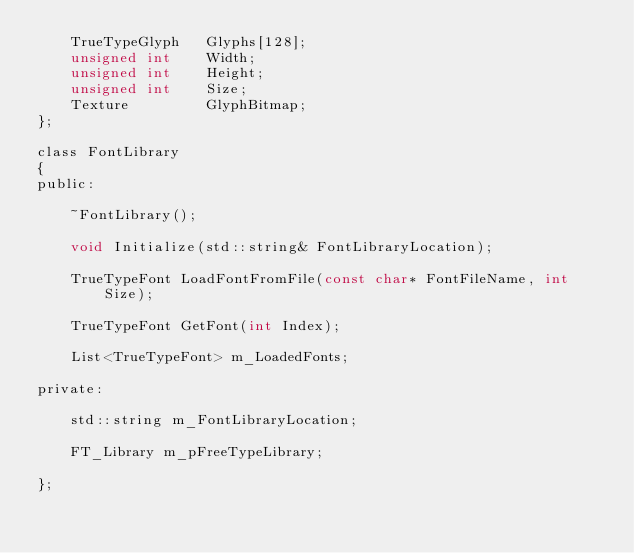Convert code to text. <code><loc_0><loc_0><loc_500><loc_500><_C_>	TrueTypeGlyph	Glyphs[128];
	unsigned int	Width;
	unsigned int	Height;
	unsigned int	Size;
	Texture			GlyphBitmap;
};

class FontLibrary
{
public:
    
    ~FontLibrary();

	void Initialize(std::string& FontLibraryLocation);

	TrueTypeFont LoadFontFromFile(const char* FontFileName, int Size);

	TrueTypeFont GetFont(int Index);
	
	List<TrueTypeFont> m_LoadedFonts;

private:

	std::string m_FontLibraryLocation;

	FT_Library m_pFreeTypeLibrary;

};</code> 